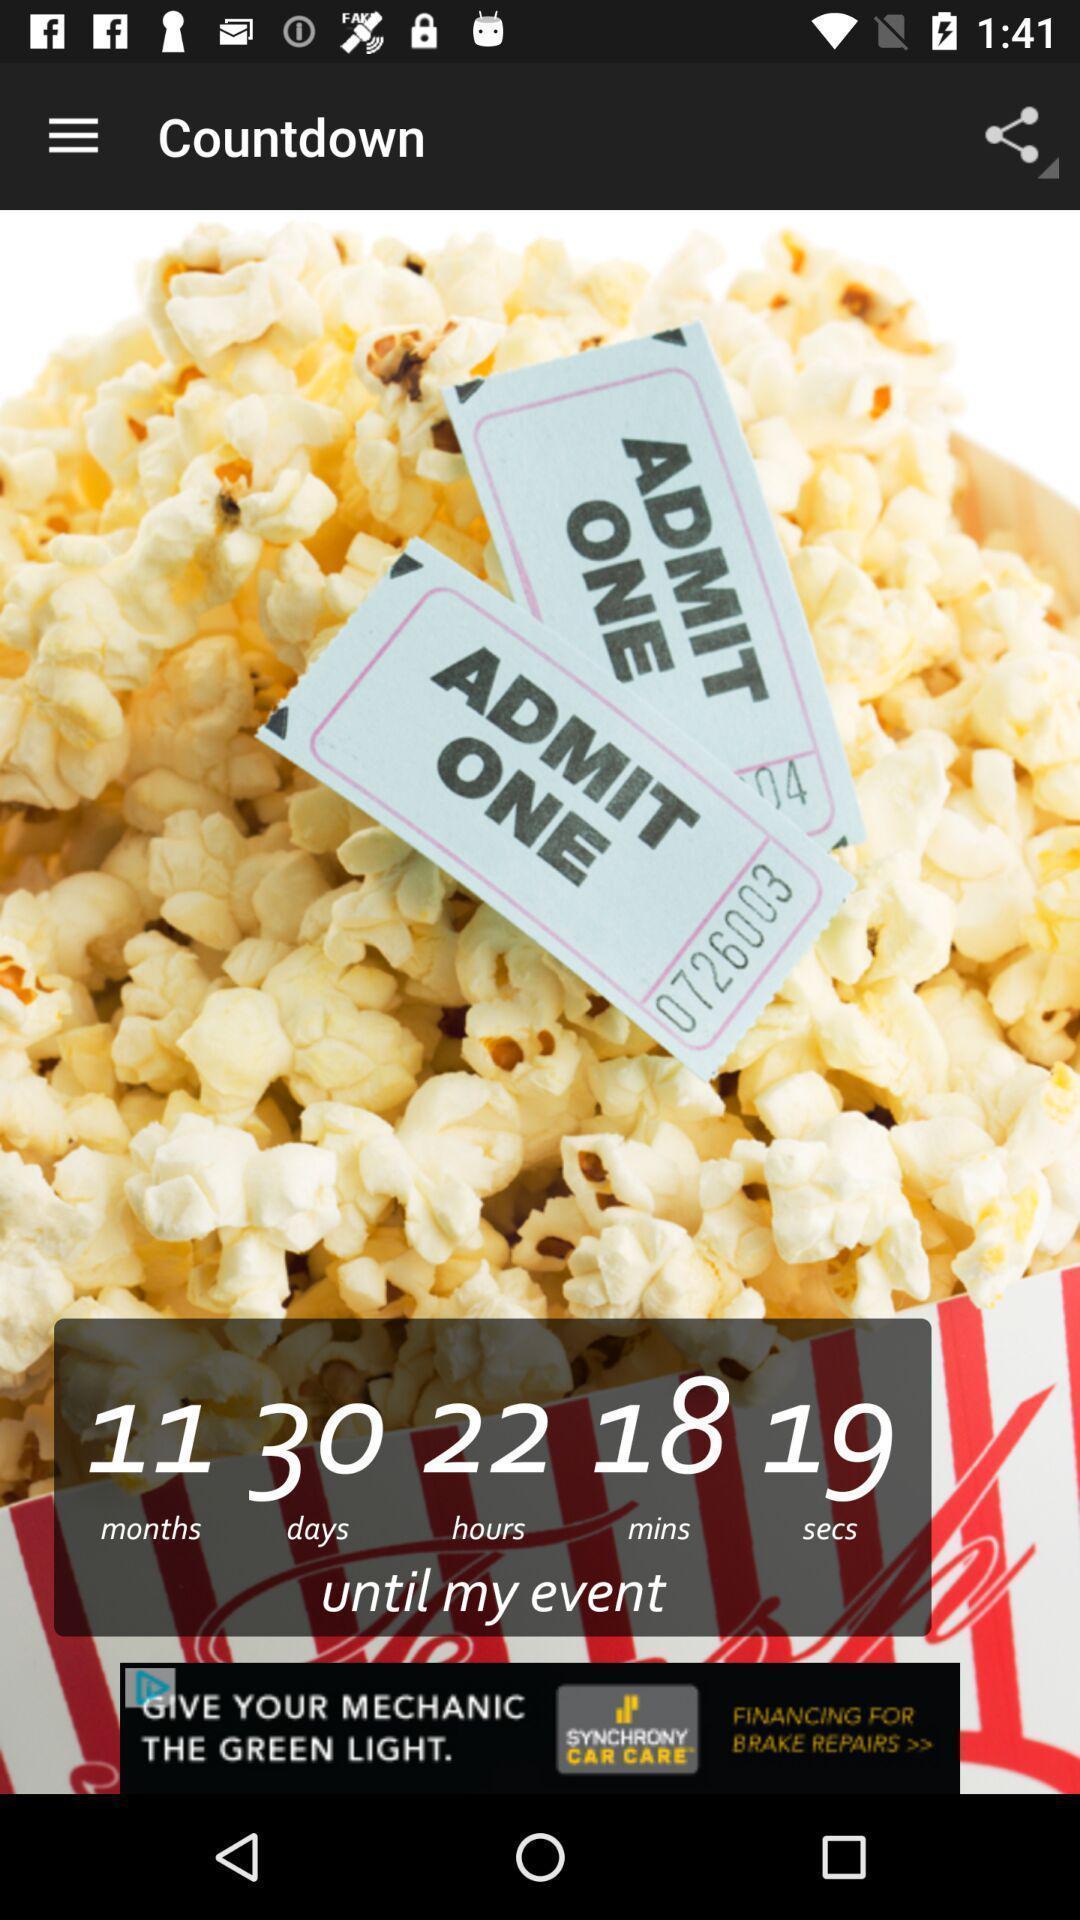Summarize the main components in this picture. Page displays event count down in app. 